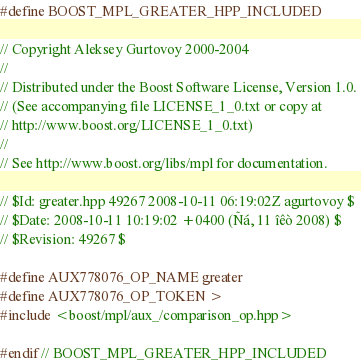Convert code to text. <code><loc_0><loc_0><loc_500><loc_500><_C++_>#define BOOST_MPL_GREATER_HPP_INCLUDED

// Copyright Aleksey Gurtovoy 2000-2004
//
// Distributed under the Boost Software License, Version 1.0. 
// (See accompanying file LICENSE_1_0.txt or copy at 
// http://www.boost.org/LICENSE_1_0.txt)
//
// See http://www.boost.org/libs/mpl for documentation.

// $Id: greater.hpp 49267 2008-10-11 06:19:02Z agurtovoy $
// $Date: 2008-10-11 10:19:02 +0400 (Ñá, 11 îêò 2008) $
// $Revision: 49267 $

#define AUX778076_OP_NAME greater
#define AUX778076_OP_TOKEN >
#include <boost/mpl/aux_/comparison_op.hpp>

#endif // BOOST_MPL_GREATER_HPP_INCLUDED
</code> 